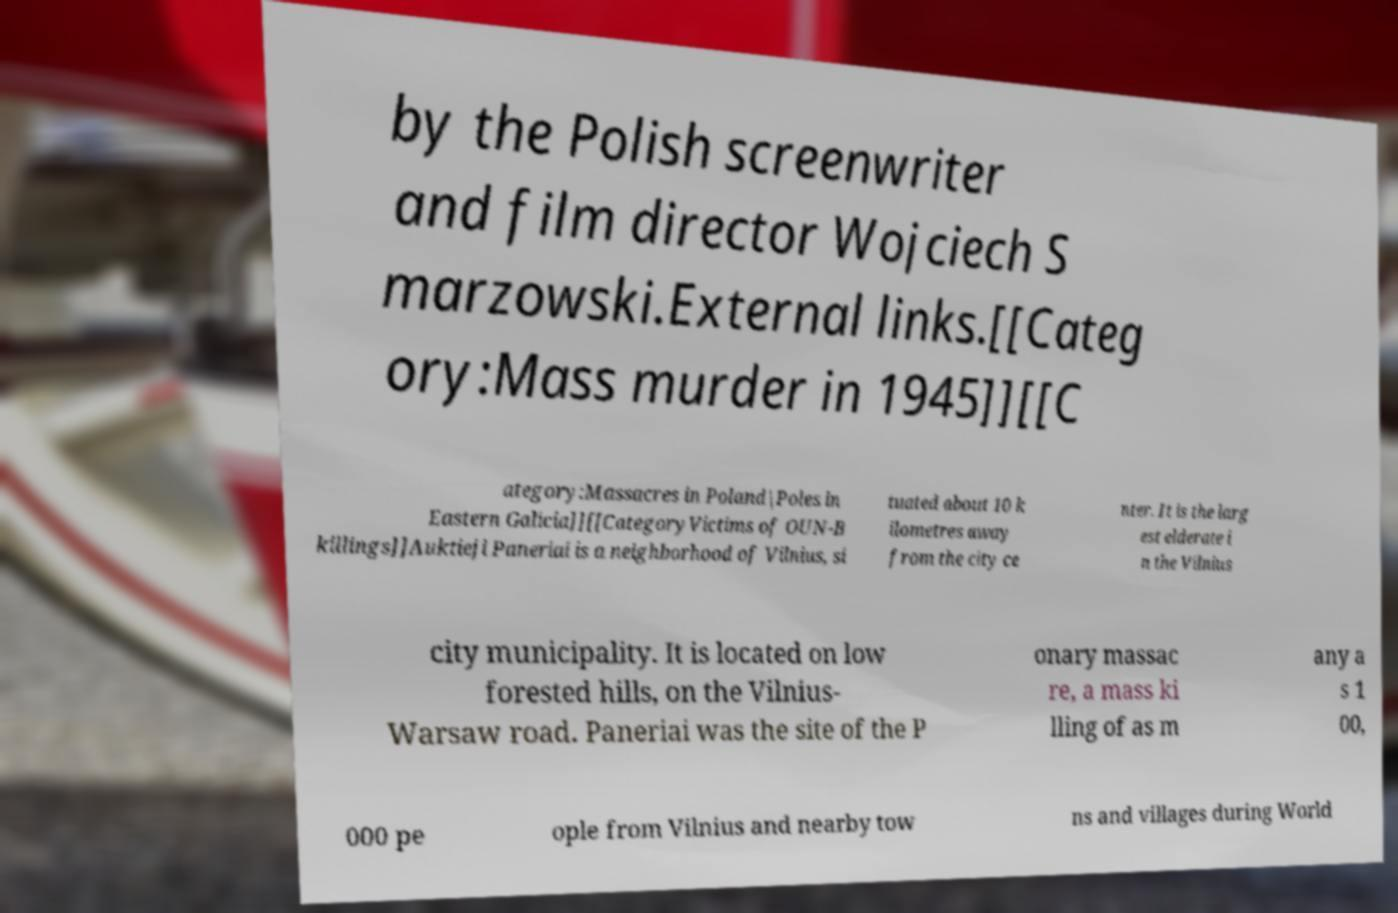I need the written content from this picture converted into text. Can you do that? by the Polish screenwriter and film director Wojciech S marzowski.External links.[[Categ ory:Mass murder in 1945]][[C ategory:Massacres in Poland|Poles in Eastern Galicia]][[CategoryVictims of OUN-B killings]]Auktieji Paneriai is a neighborhood of Vilnius, si tuated about 10 k ilometres away from the city ce nter. It is the larg est elderate i n the Vilnius city municipality. It is located on low forested hills, on the Vilnius- Warsaw road. Paneriai was the site of the P onary massac re, a mass ki lling of as m any a s 1 00, 000 pe ople from Vilnius and nearby tow ns and villages during World 